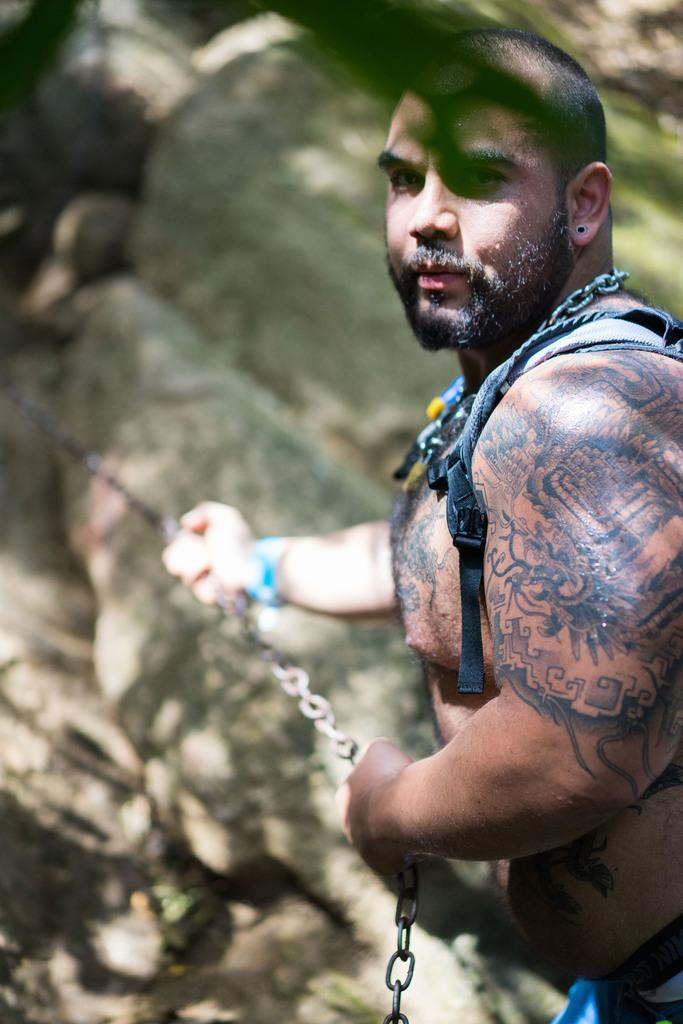Who is present in the image? There is a man in the image. What is the man doing in the image? The man is standing in the image. What is the man holding in the image? The man is holding a chain in the image. What type of natural elements can be seen in the image? There are rocks visible in the image. What type of bit is the man using to control the horn in the image? There is no bit or horn present in the image; the man is holding a chain. 